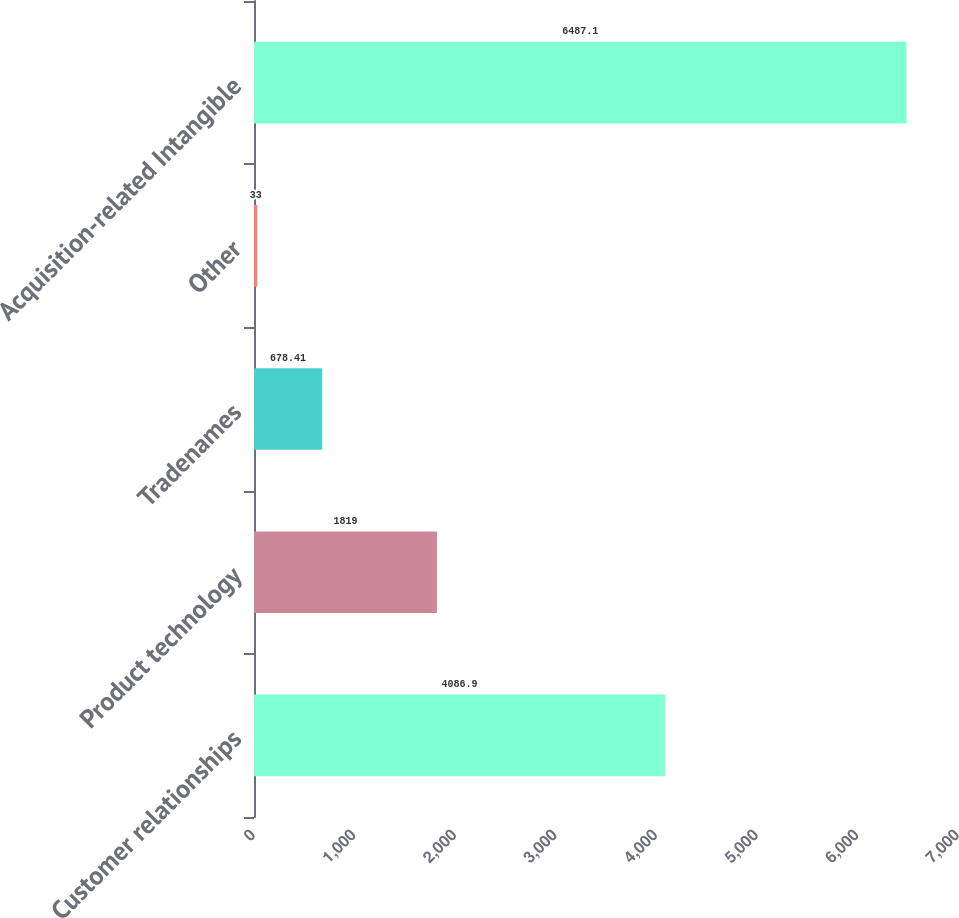Convert chart to OTSL. <chart><loc_0><loc_0><loc_500><loc_500><bar_chart><fcel>Customer relationships<fcel>Product technology<fcel>Tradenames<fcel>Other<fcel>Acquisition-related Intangible<nl><fcel>4086.9<fcel>1819<fcel>678.41<fcel>33<fcel>6487.1<nl></chart> 